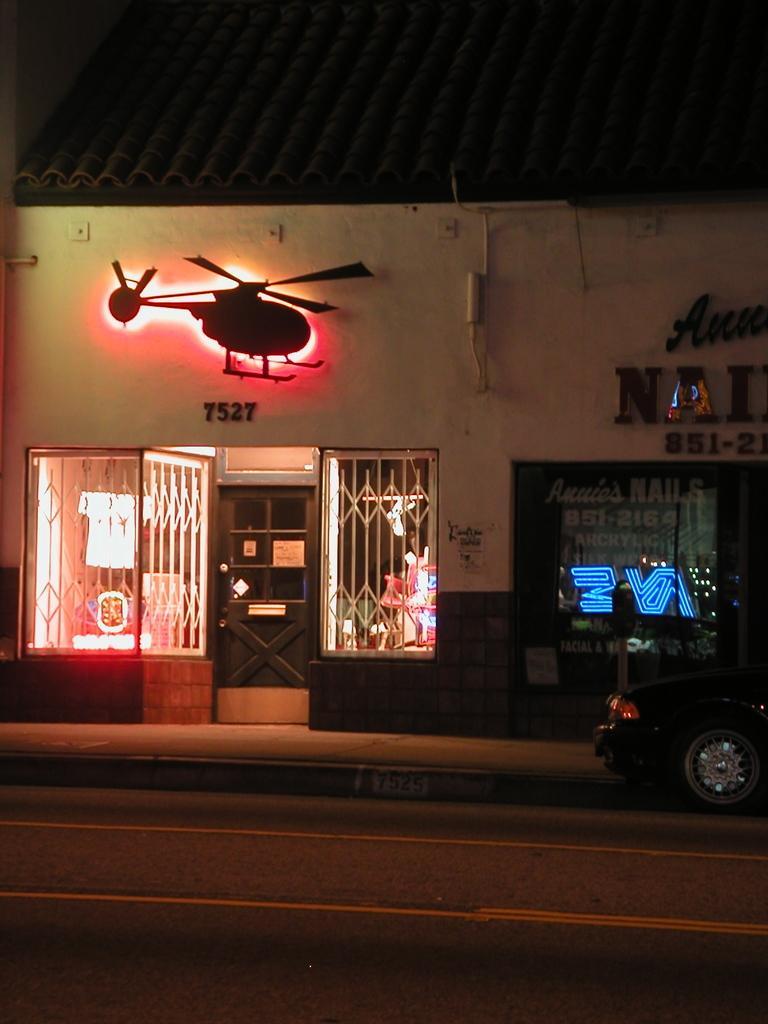Could you give a brief overview of what you see in this image? In this picture we can see a building, there is a door in the middle, on the right side there is a car, there are grilles on the left side, we can see some text on the right side. 